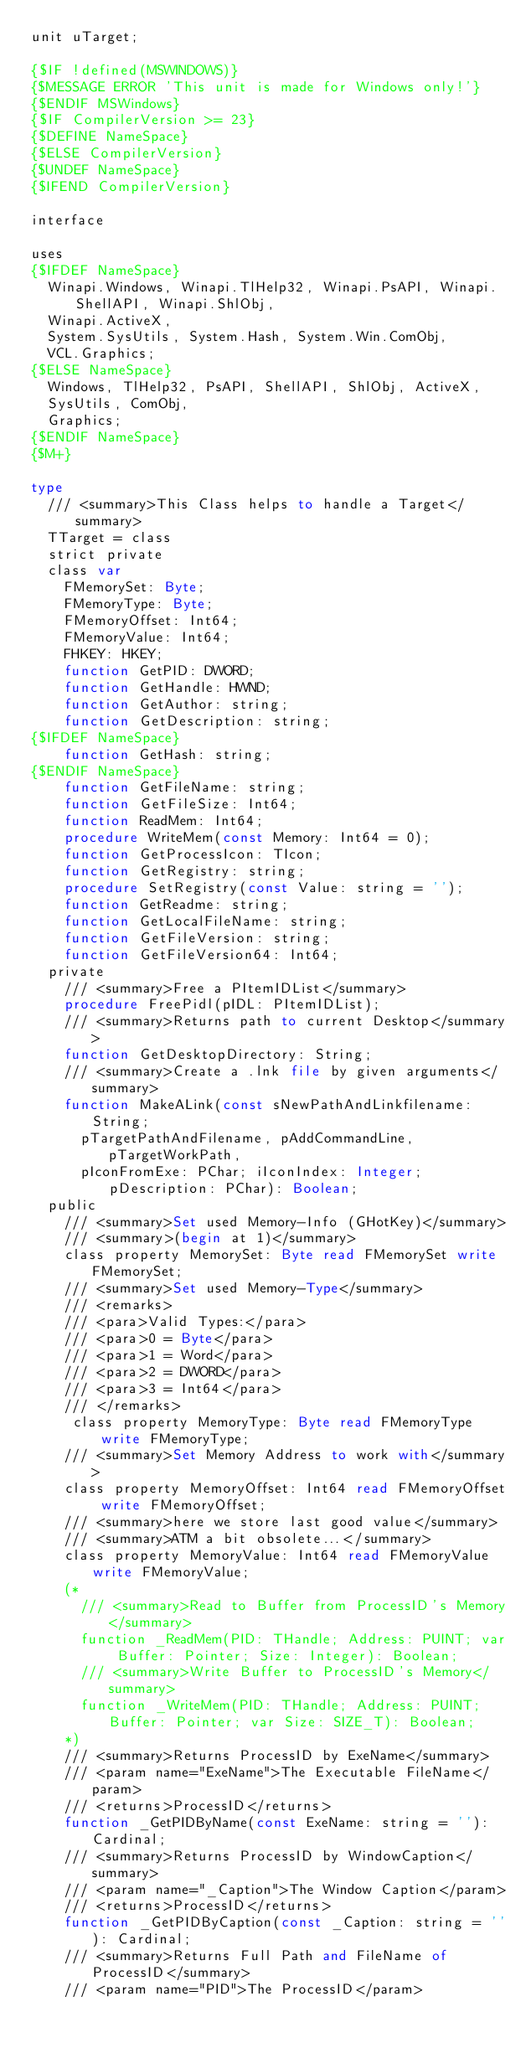<code> <loc_0><loc_0><loc_500><loc_500><_Pascal_>unit uTarget;

{$IF !defined(MSWINDOWS)}
{$MESSAGE ERROR 'This unit is made for Windows only!'}
{$ENDIF MSWindows}
{$IF CompilerVersion >= 23}
{$DEFINE NameSpace}
{$ELSE CompilerVersion}
{$UNDEF NameSpace}
{$IFEND CompilerVersion}

interface

uses
{$IFDEF NameSpace}
  Winapi.Windows, Winapi.TlHelp32, Winapi.PsAPI, Winapi.ShellAPI, Winapi.ShlObj,
  Winapi.ActiveX,
  System.SysUtils, System.Hash, System.Win.ComObj,
  VCL.Graphics;
{$ELSE NameSpace}
  Windows, TlHelp32, PsAPI, ShellAPI, ShlObj, ActiveX,
  SysUtils, ComObj,
  Graphics;
{$ENDIF NameSpace}
{$M+}

type
  /// <summary>This Class helps to handle a Target</summary>
  TTarget = class
  strict private
  class var
    FMemorySet: Byte;
    FMemoryType: Byte;
    FMemoryOffset: Int64;
    FMemoryValue: Int64;
    FHKEY: HKEY;
    function GetPID: DWORD;
    function GetHandle: HWND;
    function GetAuthor: string;
    function GetDescription: string;
{$IFDEF NameSpace}
    function GetHash: string;
{$ENDIF NameSpace}
    function GetFileName: string;
    function GetFileSize: Int64;
    function ReadMem: Int64;
    procedure WriteMem(const Memory: Int64 = 0);
    function GetProcessIcon: TIcon;
    function GetRegistry: string;
    procedure SetRegistry(const Value: string = '');
    function GetReadme: string;
    function GetLocalFileName: string;
    function GetFileVersion: string;
    function GetFileVersion64: Int64;
  private
    /// <summary>Free a PItemIDList</summary>
    procedure FreePidl(pIDL: PItemIDList);
    /// <summary>Returns path to current Desktop</summary>
    function GetDesktopDirectory: String;
    /// <summary>Create a .lnk file by given arguments</summary>
    function MakeALink(const sNewPathAndLinkfilename: String;
      pTargetPathAndFilename, pAddCommandLine, pTargetWorkPath,
      pIconFromExe: PChar; iIconIndex: Integer; pDescription: PChar): Boolean;
  public
    /// <summary>Set used Memory-Info (GHotKey)</summary>
    /// <summary>(begin at 1)</summary>
    class property MemorySet: Byte read FMemorySet write FMemorySet;
    /// <summary>Set used Memory-Type</summary>
    /// <remarks>
    /// <para>Valid Types:</para>
    /// <para>0 = Byte</para>
    /// <para>1 = Word</para>
    /// <para>2 = DWORD</para>
    /// <para>3 = Int64</para>
    /// </remarks>
     class property MemoryType: Byte read FMemoryType write FMemoryType;
    /// <summary>Set Memory Address to work with</summary>
    class property MemoryOffset: Int64 read FMemoryOffset write FMemoryOffset;
    /// <summary>here we store last good value</summary>
    /// <summary>ATM a bit obsolete...</summary>
    class property MemoryValue: Int64 read FMemoryValue write FMemoryValue;
    (*
      /// <summary>Read to Buffer from ProcessID's Memory</summary>
      function _ReadMem(PID: THandle; Address: PUINT; var Buffer: Pointer; Size: Integer): Boolean;
      /// <summary>Write Buffer to ProcessID's Memory</summary>
      function _WriteMem(PID: THandle; Address: PUINT; Buffer: Pointer; var Size: SIZE_T): Boolean;
    *)
    /// <summary>Returns ProcessID by ExeName</summary>
    /// <param name="ExeName">The Executable FileName</param>
    /// <returns>ProcessID</returns>
    function _GetPIDByName(const ExeName: string = ''): Cardinal;
    /// <summary>Returns ProcessID by WindowCaption</summary>
    /// <param name="_Caption">The Window Caption</param>
    /// <returns>ProcessID</returns>
    function _GetPIDByCaption(const _Caption: string = ''): Cardinal;
    /// <summary>Returns Full Path and FileName of ProcessID</summary>
    /// <param name="PID">The ProcessID</param></code> 